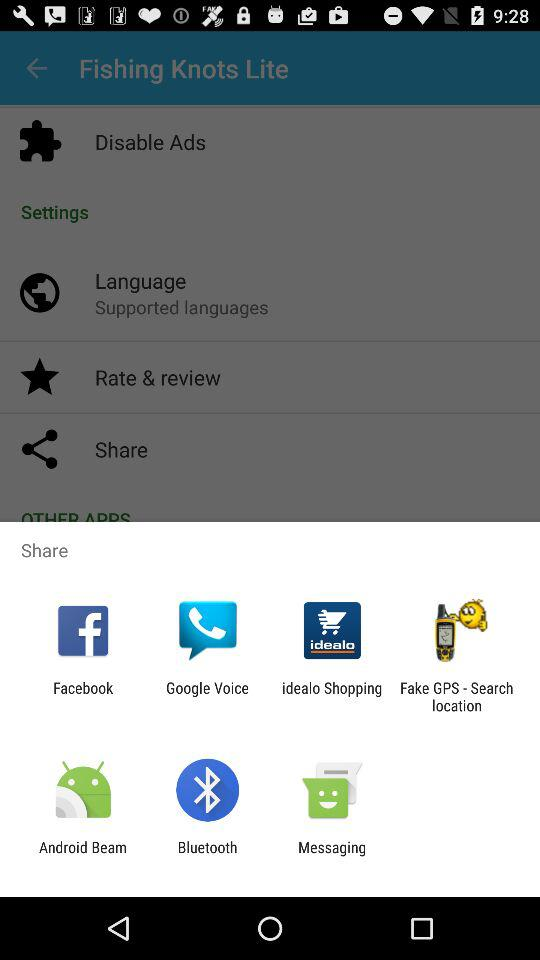Which languages are supported by the application?
When the provided information is insufficient, respond with <no answer>. <no answer> 